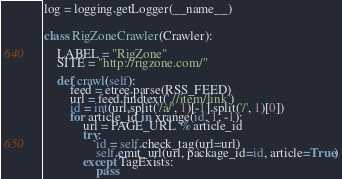<code> <loc_0><loc_0><loc_500><loc_500><_Python_>
log = logging.getLogger(__name__)


class RigZoneCrawler(Crawler):

    LABEL = "RigZone"
    SITE = "http://rigzone.com/"

    def crawl(self):
        feed = etree.parse(RSS_FEED)
        url = feed.findtext('.//item/link')
        id = int(url.split('/a/', 1)[-1].split('/', 1)[0])
        for article_id in xrange(id, 1, -1):
            url = PAGE_URL % article_id
            try:
                id = self.check_tag(url=url)
                self.emit_url(url, package_id=id, article=True)
            except TagExists:
                pass
</code> 